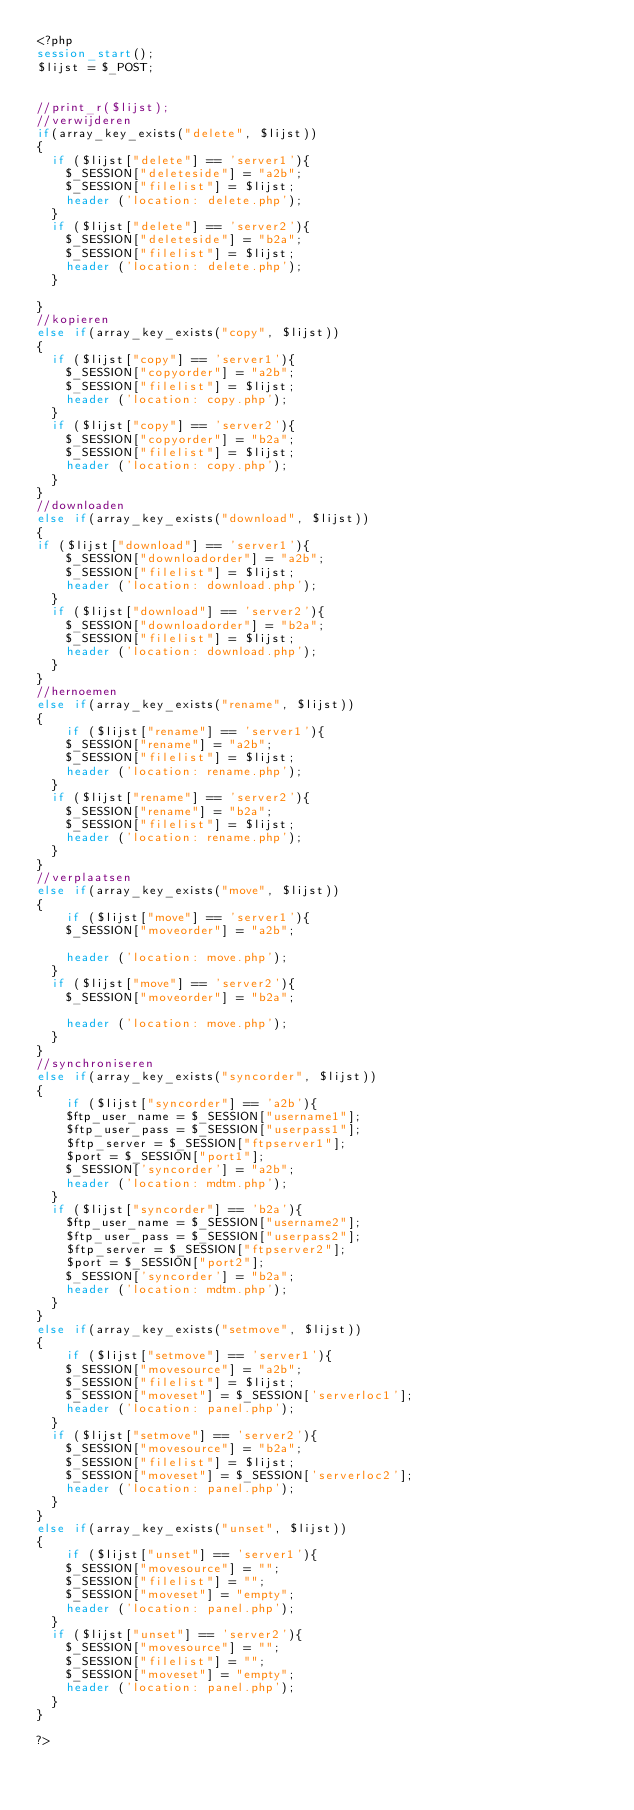<code> <loc_0><loc_0><loc_500><loc_500><_PHP_><?php
session_start();
$lijst = $_POST;


//print_r($lijst);
//verwijderen
if(array_key_exists("delete", $lijst))
{
	if ($lijst["delete"] == 'server1'){
		$_SESSION["deleteside"] = "a2b";
		$_SESSION["filelist"] = $lijst;
		header ('location: delete.php');
	}
	if ($lijst["delete"] == 'server2'){
		$_SESSION["deleteside"] = "b2a";
		$_SESSION["filelist"] = $lijst;
		header ('location: delete.php');
	}
	
}
//kopieren
else if(array_key_exists("copy", $lijst))
{
	if ($lijst["copy"] == 'server1'){
		$_SESSION["copyorder"] = "a2b";
		$_SESSION["filelist"] = $lijst;
		header ('location: copy.php');
	}
	if ($lijst["copy"] == 'server2'){
		$_SESSION["copyorder"] = "b2a";
		$_SESSION["filelist"] = $lijst;
		header ('location: copy.php');
	}
}
//downloaden
else if(array_key_exists("download", $lijst))
{
if ($lijst["download"] == 'server1'){
		$_SESSION["downloadorder"] = "a2b";
		$_SESSION["filelist"] = $lijst;
		header ('location: download.php');
	}
	if ($lijst["download"] == 'server2'){
		$_SESSION["downloadorder"] = "b2a";
		$_SESSION["filelist"] = $lijst;
		header ('location: download.php');
	}
}
//hernoemen
else if(array_key_exists("rename", $lijst))
{
		if ($lijst["rename"] == 'server1'){
		$_SESSION["rename"] = "a2b";
		$_SESSION["filelist"] = $lijst;
		header ('location: rename.php');
	}
	if ($lijst["rename"] == 'server2'){
		$_SESSION["rename"] = "b2a";
		$_SESSION["filelist"] = $lijst;
		header ('location: rename.php');
	}
}
//verplaatsen
else if(array_key_exists("move", $lijst))
{
		if ($lijst["move"] == 'server1'){
		$_SESSION["moveorder"] = "a2b";
		
		header ('location: move.php');
	}
	if ($lijst["move"] == 'server2'){
		$_SESSION["moveorder"] = "b2a";
		
		header ('location: move.php');
	}
}
//synchroniseren
else if(array_key_exists("syncorder", $lijst))
{
		if ($lijst["syncorder"] == 'a2b'){
		$ftp_user_name = $_SESSION["username1"];
		$ftp_user_pass = $_SESSION["userpass1"];
		$ftp_server = $_SESSION["ftpserver1"];
		$port = $_SESSION["port1"];
		$_SESSION['syncorder'] = "a2b";
		header ('location: mdtm.php');
	}
	if ($lijst["syncorder"] == 'b2a'){
		$ftp_user_name = $_SESSION["username2"];
		$ftp_user_pass = $_SESSION["userpass2"];
		$ftp_server = $_SESSION["ftpserver2"];
		$port = $_SESSION["port2"];
		$_SESSION['syncorder'] = "b2a";
		header ('location: mdtm.php');
	}
}
else if(array_key_exists("setmove", $lijst))
{
		if ($lijst["setmove"] == 'server1'){
		$_SESSION["movesource"] = "a2b";
		$_SESSION["filelist"] = $lijst;
		$_SESSION["moveset"] = $_SESSION['serverloc1'];
		header ('location: panel.php');
	}
	if ($lijst["setmove"] == 'server2'){
		$_SESSION["movesource"] = "b2a";
		$_SESSION["filelist"] = $lijst;
		$_SESSION["moveset"] = $_SESSION['serverloc2'];
		header ('location: panel.php');
	}
}
else if(array_key_exists("unset", $lijst))
{
		if ($lijst["unset"] == 'server1'){
		$_SESSION["movesource"] = "";
		$_SESSION["filelist"] = "";
		$_SESSION["moveset"] = "empty";
		header ('location: panel.php');
	}
	if ($lijst["unset"] == 'server2'){
		$_SESSION["movesource"] = "";
		$_SESSION["filelist"] = "";
		$_SESSION["moveset"] = "empty";
		header ('location: panel.php');
	}
}

?></code> 